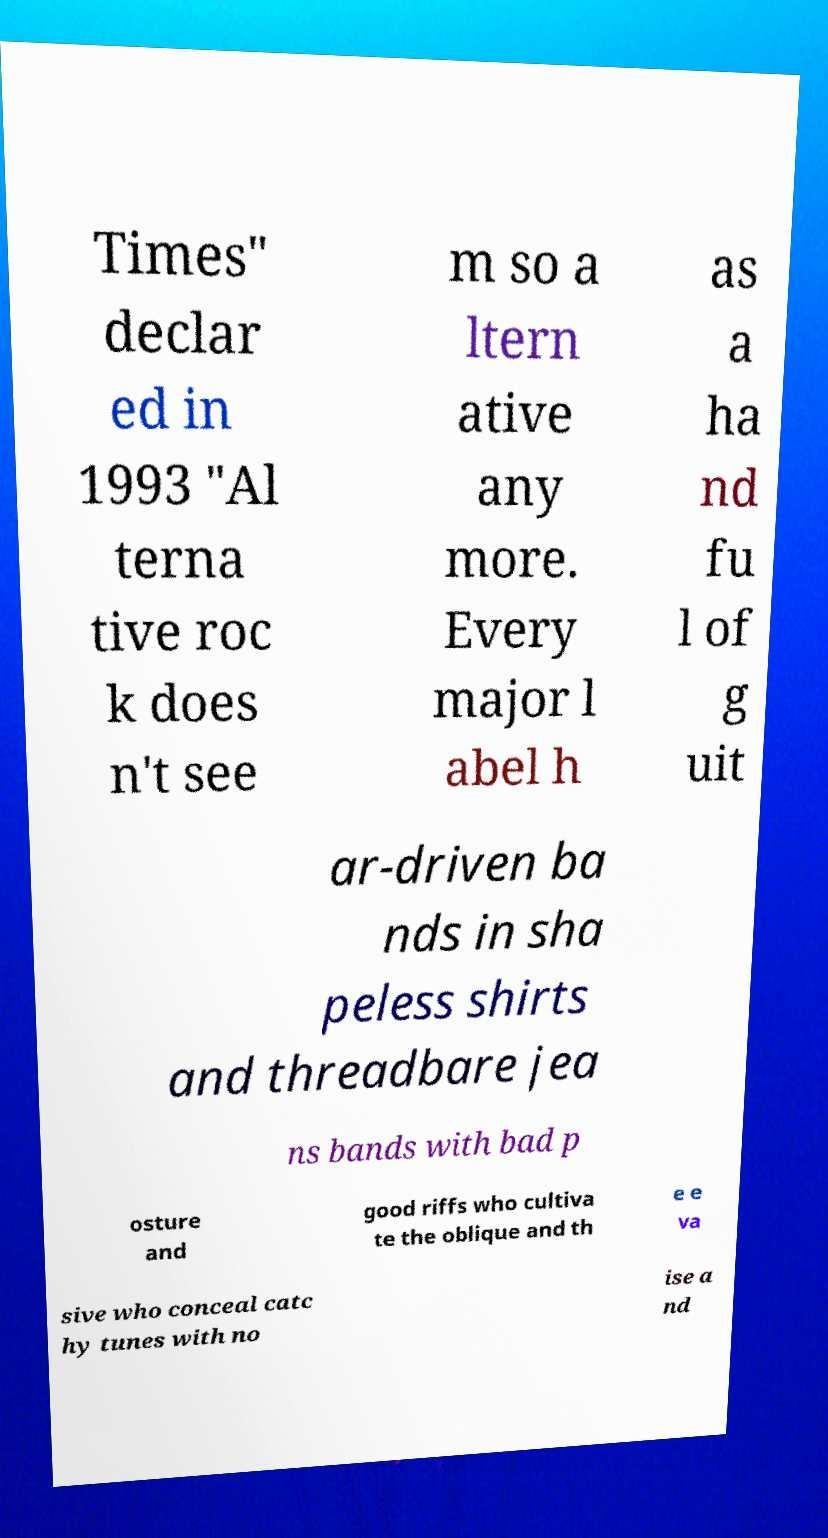Could you extract and type out the text from this image? Times" declar ed in 1993 "Al terna tive roc k does n't see m so a ltern ative any more. Every major l abel h as a ha nd fu l of g uit ar-driven ba nds in sha peless shirts and threadbare jea ns bands with bad p osture and good riffs who cultiva te the oblique and th e e va sive who conceal catc hy tunes with no ise a nd 